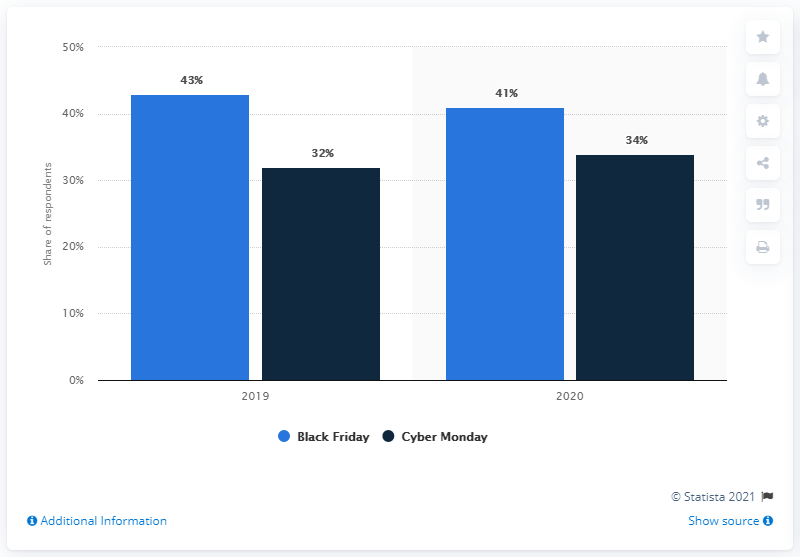Identify some key points in this picture. On which day of the week do Canadian consumers plan to shop during Black Friday? 